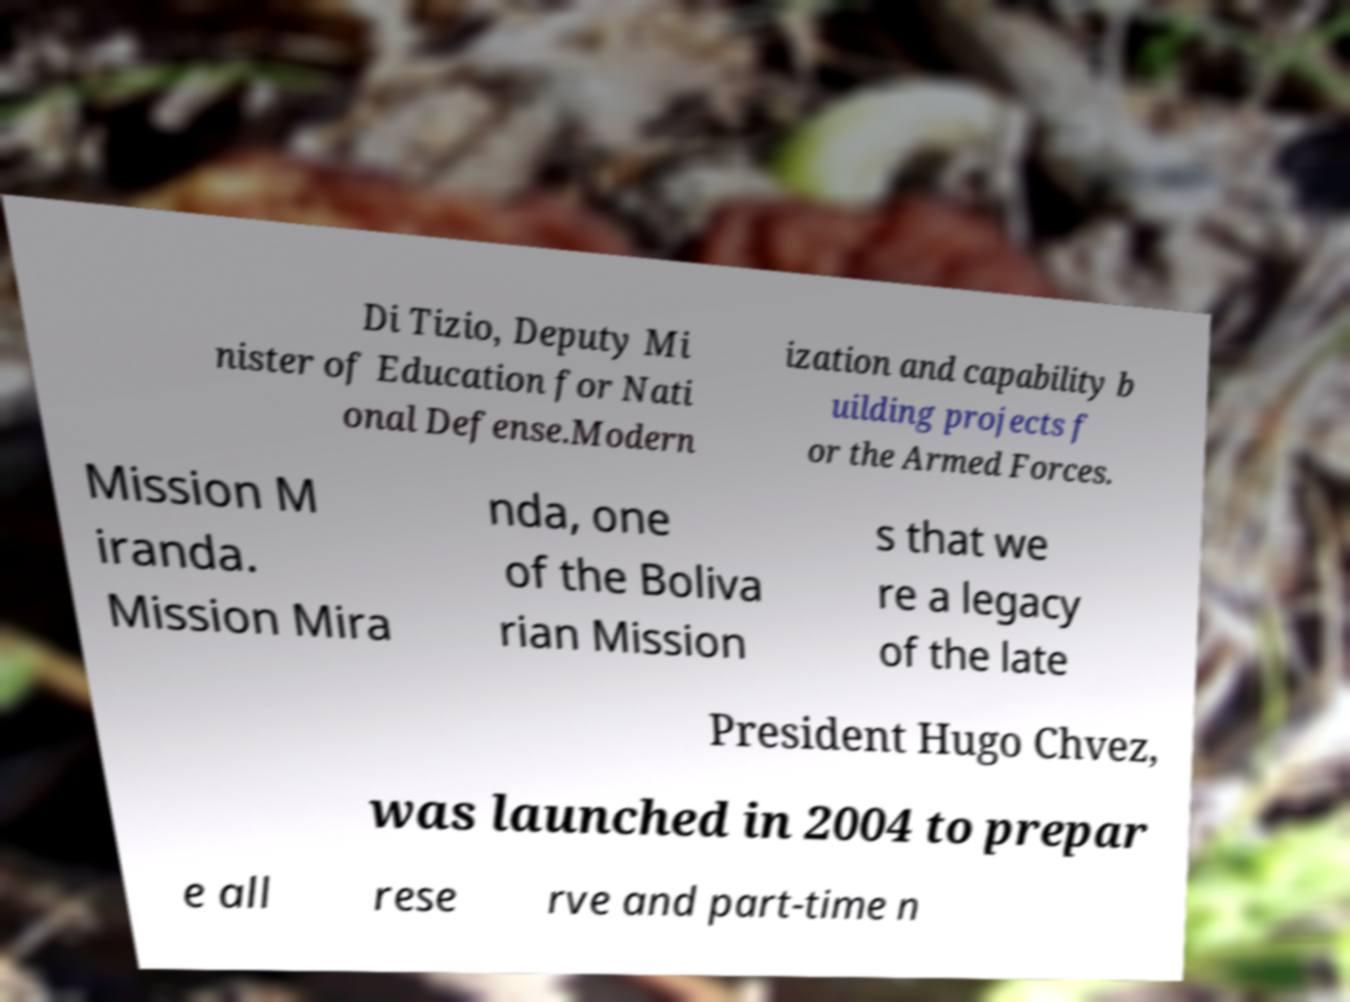Please read and relay the text visible in this image. What does it say? Di Tizio, Deputy Mi nister of Education for Nati onal Defense.Modern ization and capability b uilding projects f or the Armed Forces. Mission M iranda. Mission Mira nda, one of the Boliva rian Mission s that we re a legacy of the late President Hugo Chvez, was launched in 2004 to prepar e all rese rve and part-time n 